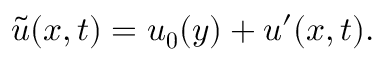Convert formula to latex. <formula><loc_0><loc_0><loc_500><loc_500>\tilde { u } ( x , t ) = u _ { 0 } ( y ) + u ^ { \prime } ( x , t ) .</formula> 